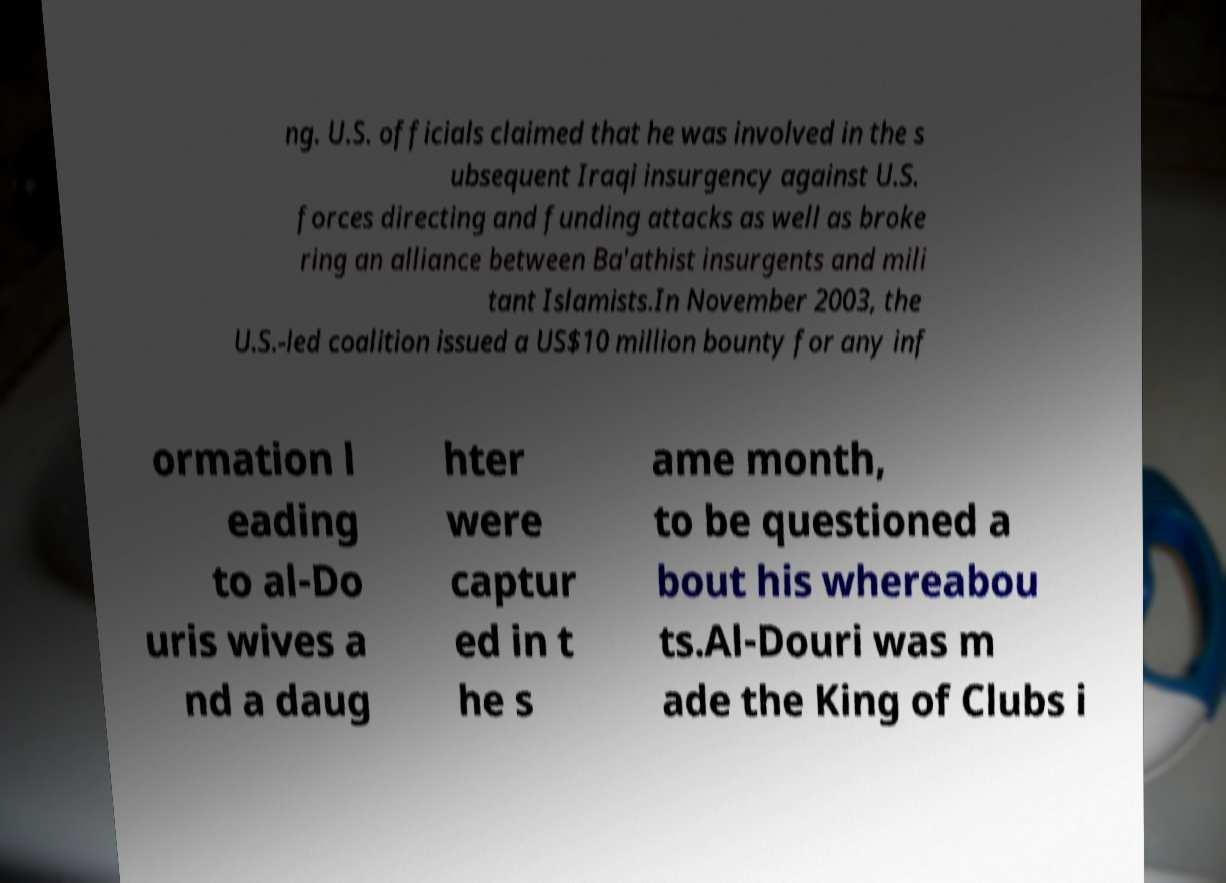Can you read and provide the text displayed in the image?This photo seems to have some interesting text. Can you extract and type it out for me? ng. U.S. officials claimed that he was involved in the s ubsequent Iraqi insurgency against U.S. forces directing and funding attacks as well as broke ring an alliance between Ba'athist insurgents and mili tant Islamists.In November 2003, the U.S.-led coalition issued a US$10 million bounty for any inf ormation l eading to al-Do uris wives a nd a daug hter were captur ed in t he s ame month, to be questioned a bout his whereabou ts.Al-Douri was m ade the King of Clubs i 